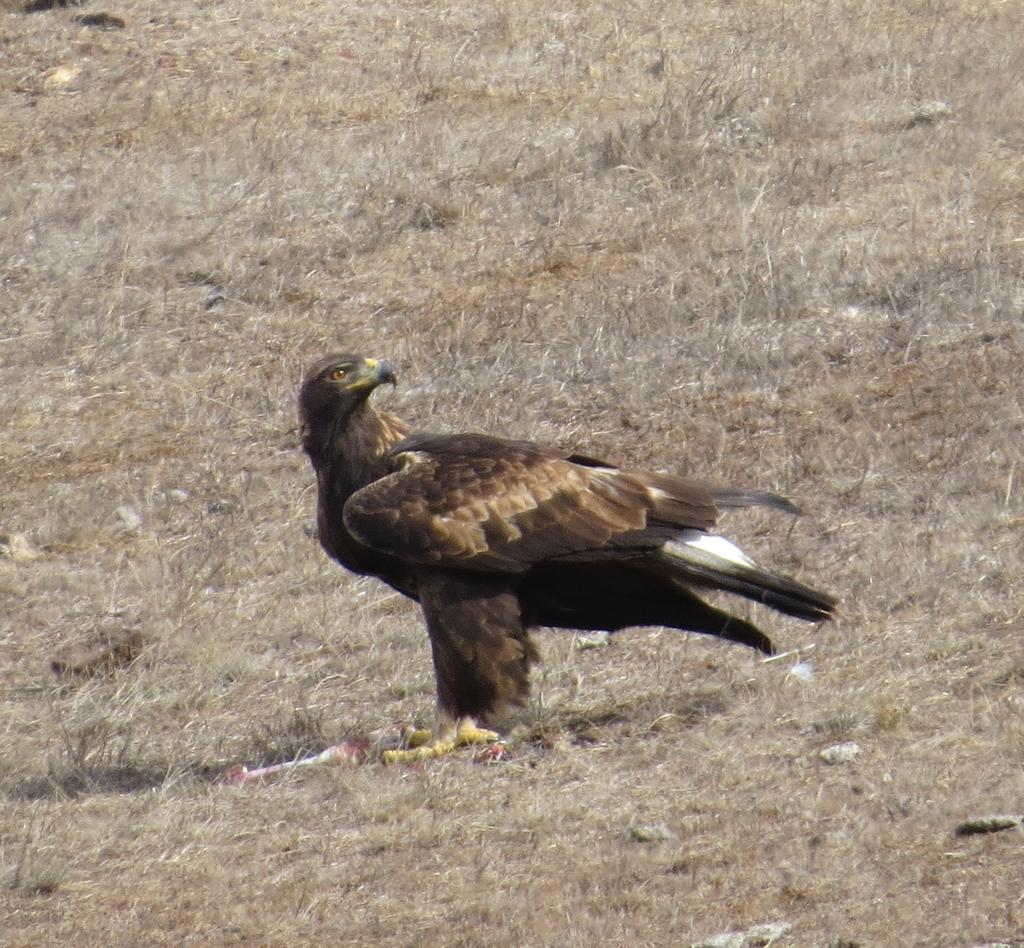Where was the image taken? The image is taken outdoors. What type of surface can be seen in the image? There is a ground with grass in the image. What animal is present in the image? There is an eagle on the ground in the image. What is the price of the bottle in the image? There is no bottle present in the image, so it is not possible to determine its price. 